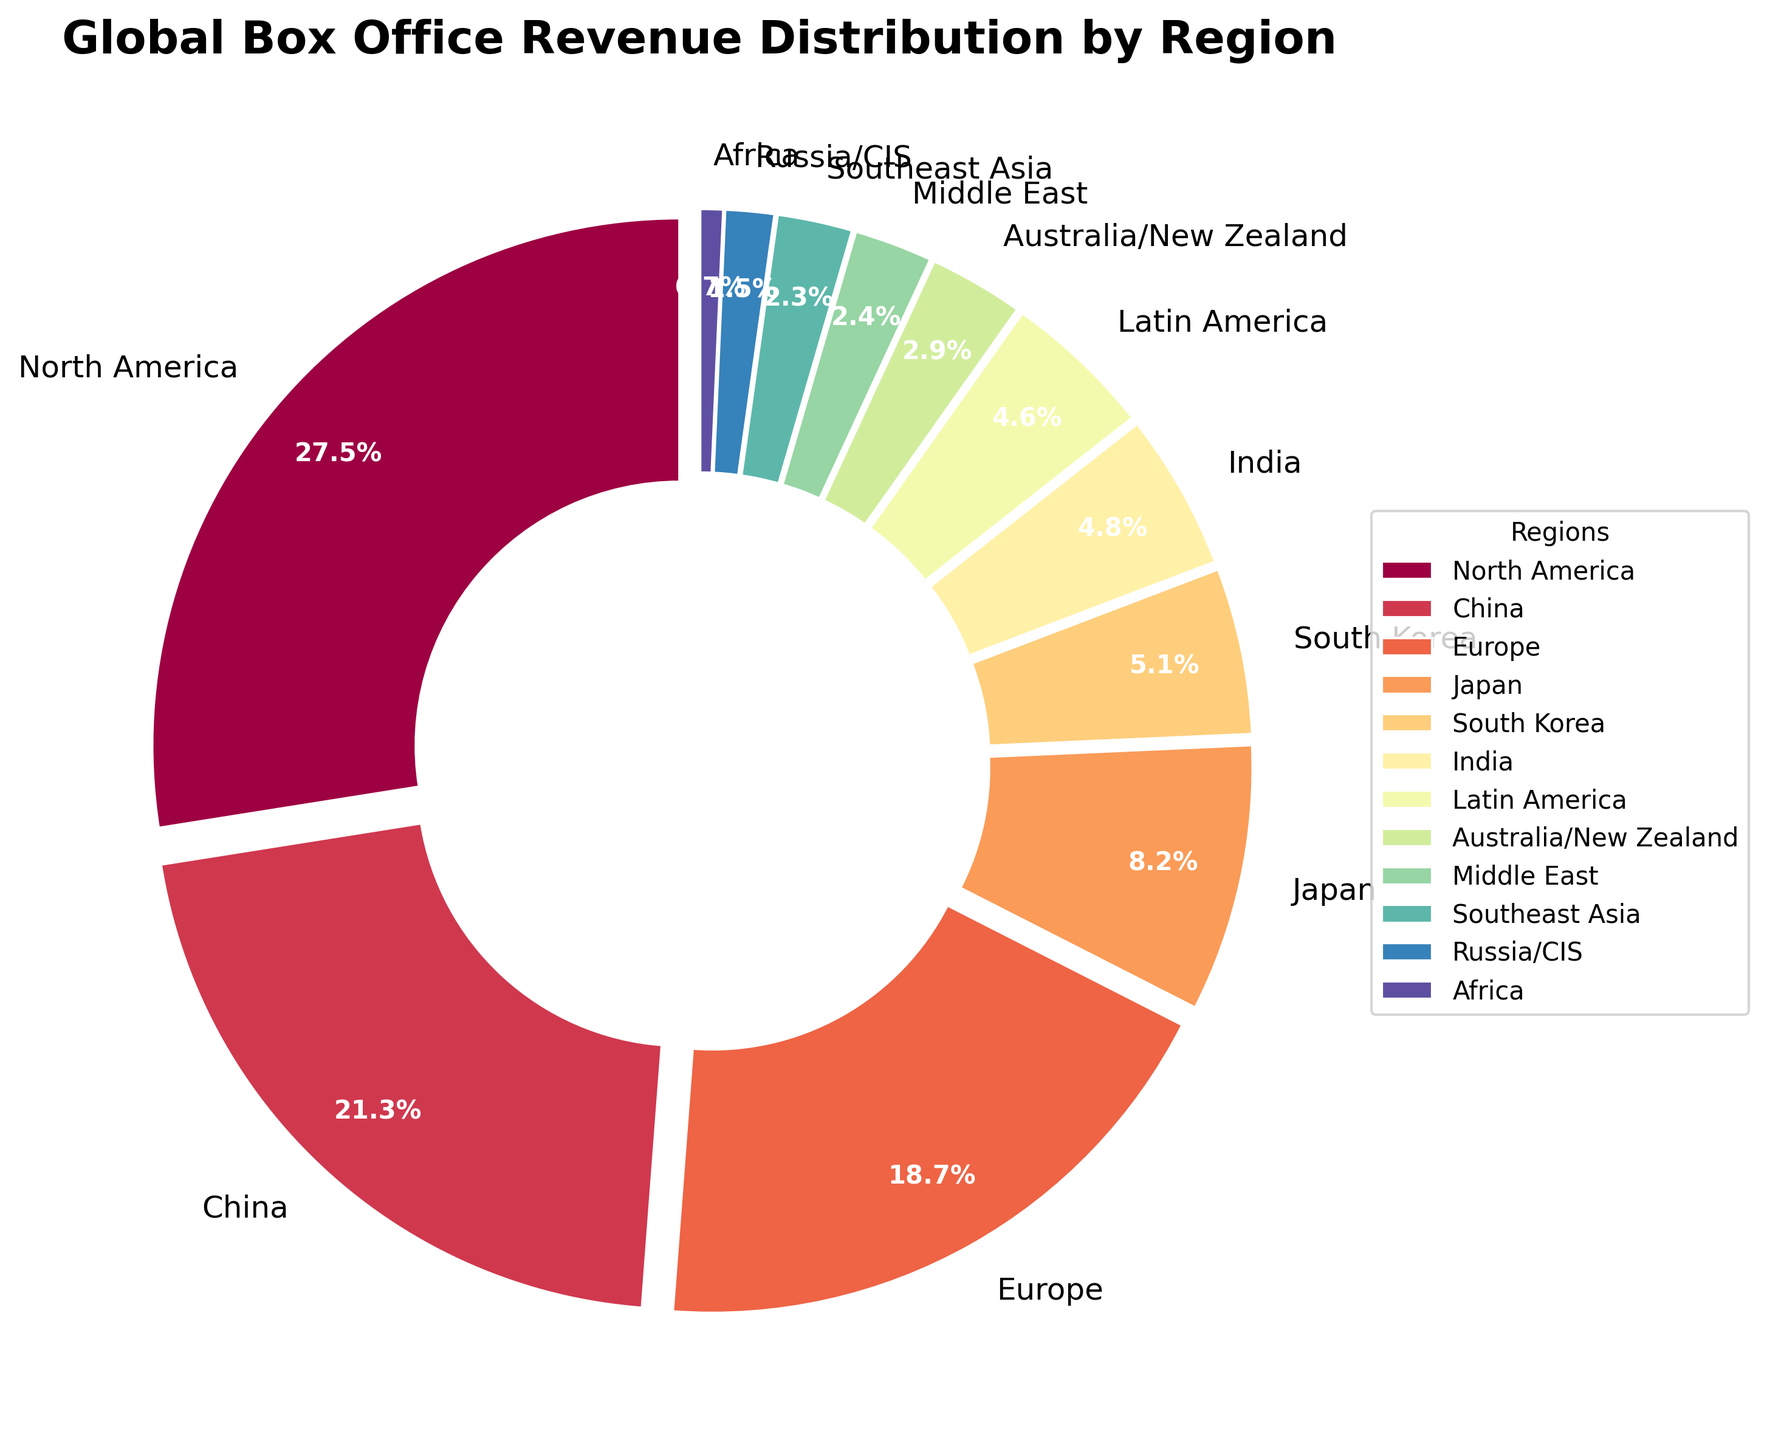Which region has the highest box office revenue percentage? The figure shows that North America has the largest slice, indicating the highest percentage of box office revenue.
Answer: North America Which region contributes more to the global box office revenue, Europe or China? The figure shows the percentages for Europe and China. China has a slice labeled 21.3%, and Europe has a slice labeled 18.7%.
Answer: China How much greater is the percentage of box office revenue from North America compared to South Korea? North America has 27.5% and South Korea has 5.1%. Subtract South Korea's percentage from North America's: 27.5% - 5.1% = 22.4%.
Answer: 22.4% What is the combined percentage of box office revenue from Japan, South Korea, and India? The percentages are Japan (8.2%), South Korea (5.1%), and India (4.8%). Add these percentages together: 8.2% + 5.1% + 4.8% = 18.1%.
Answer: 18.1% Which regions have a box office revenue percentage that is less than 5%? The figure shows regions with the following percentages below 5%: South Korea (5.1%), India (4.8%), Latin America (4.6%), Australia/New Zealand (2.9%), Middle East (2.4%), Southeast Asia (2.3%), Russia/CIS (1.5%), and Africa (0.7%).
Answer: India, Latin America, Australia/New Zealand, Middle East, Southeast Asia, Russia/CIS, Africa If you combine the box office percentages of China, Europe, and Latin America, is their total greater than North America? Add China's 21.3%, Europe's 18.7%, and Latin America's 4.6%. The total is 21.3% + 18.7% + 4.6% = 44.6%. North America's percentage is 27.5%. Since 44.6% > 27.5%, the combined percentage is greater.
Answer: Yes Which region has the smallest share of the global box office revenue? The figure shows that Africa has the smallest slice, indicating the lowest percentage of box office revenue at 0.7%.
Answer: Africa What is the average percentage of box office revenue for Europe, Japan, and Russia/CIS? The percentages are Europe (18.7%), Japan (8.2%), and Russia/CIS (1.5%). Sum these percentages and divide by the number of regions: (18.7% + 8.2% + 1.5%) / 3 = 28.4% / 3 ≈ 9.47%.
Answer: 9.47% Which region generates more box office revenue, Australia/New Zealand or Southeast Asia? The figure shows percentages for both regions: Australia/New Zealand at 2.9% and Southeast Asia at 2.3%. Since 2.9% > 2.3%, Australia/New Zealand generates more revenue.
Answer: Australia/New Zealand 